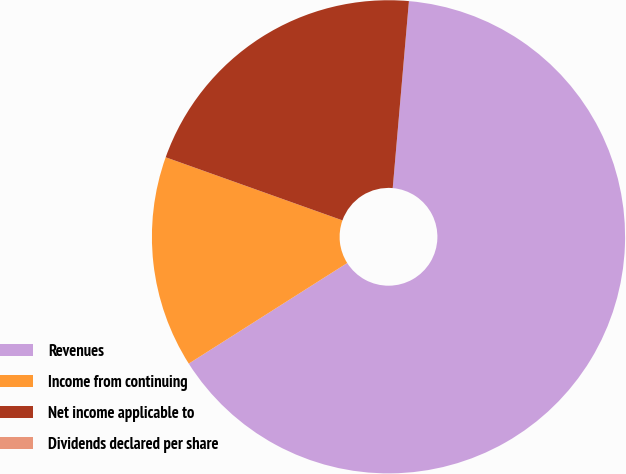<chart> <loc_0><loc_0><loc_500><loc_500><pie_chart><fcel>Revenues<fcel>Income from continuing<fcel>Net income applicable to<fcel>Dividends declared per share<nl><fcel>64.62%<fcel>14.46%<fcel>20.92%<fcel>0.0%<nl></chart> 